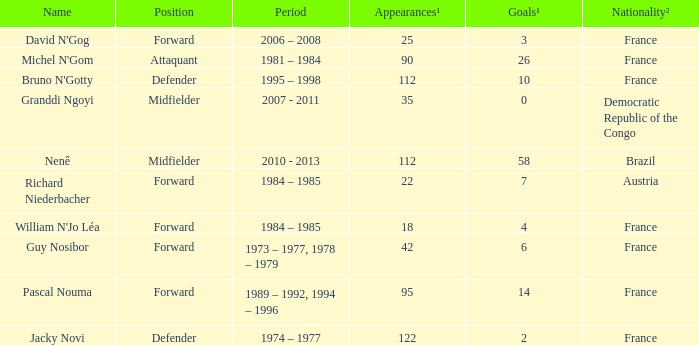List the number of active years for attaquant. 1981 – 1984. 